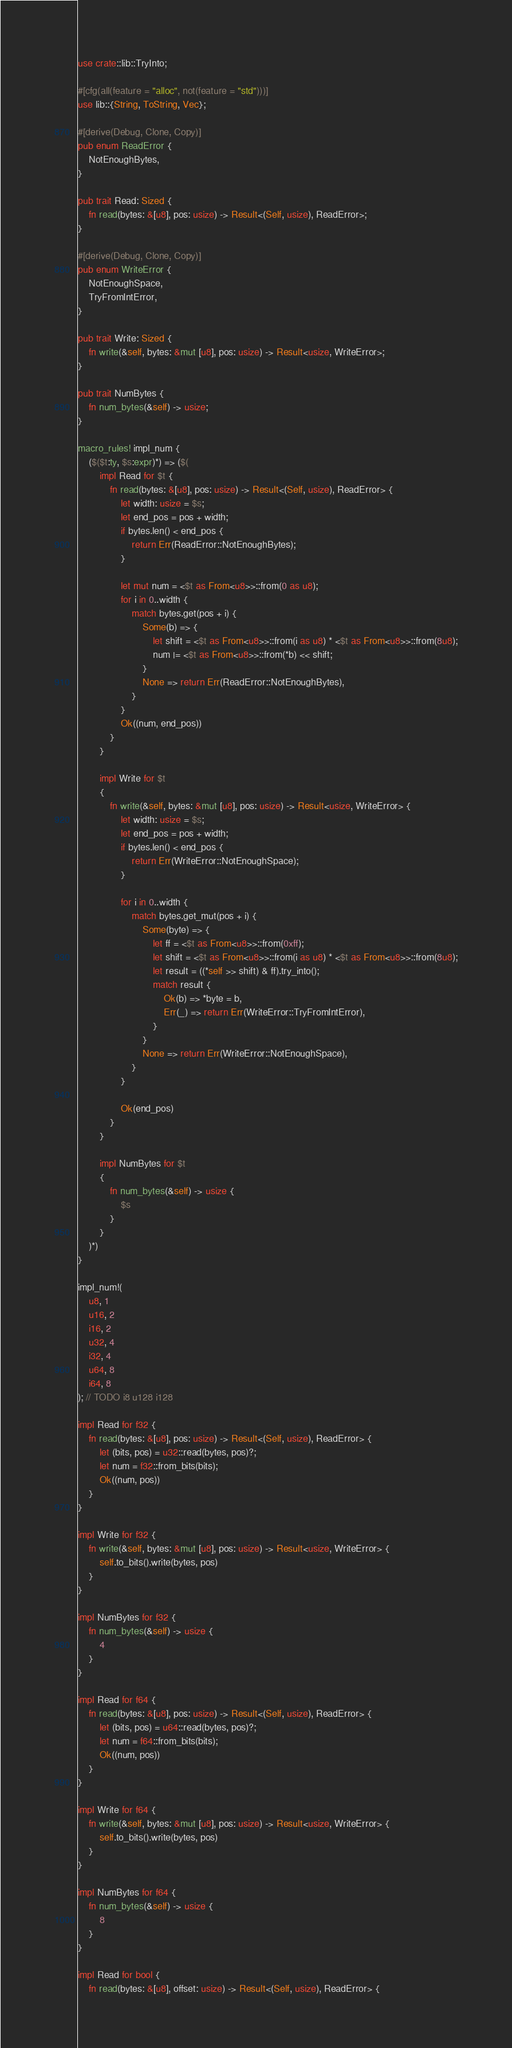Convert code to text. <code><loc_0><loc_0><loc_500><loc_500><_Rust_>use crate::lib::TryInto;

#[cfg(all(feature = "alloc", not(feature = "std")))]
use lib::{String, ToString, Vec};

#[derive(Debug, Clone, Copy)]
pub enum ReadError {
    NotEnoughBytes,
}

pub trait Read: Sized {
    fn read(bytes: &[u8], pos: usize) -> Result<(Self, usize), ReadError>;
}

#[derive(Debug, Clone, Copy)]
pub enum WriteError {
    NotEnoughSpace,
    TryFromIntError,
}

pub trait Write: Sized {
    fn write(&self, bytes: &mut [u8], pos: usize) -> Result<usize, WriteError>;
}

pub trait NumBytes {
    fn num_bytes(&self) -> usize;
}

macro_rules! impl_num {
    ($($t:ty, $s:expr)*) => ($(
        impl Read for $t {
            fn read(bytes: &[u8], pos: usize) -> Result<(Self, usize), ReadError> {
                let width: usize = $s;
                let end_pos = pos + width;
                if bytes.len() < end_pos {
                    return Err(ReadError::NotEnoughBytes);
                }

                let mut num = <$t as From<u8>>::from(0 as u8);
                for i in 0..width {
                    match bytes.get(pos + i) {
                        Some(b) => {
                            let shift = <$t as From<u8>>::from(i as u8) * <$t as From<u8>>::from(8u8);
                            num |= <$t as From<u8>>::from(*b) << shift;
                        }
                        None => return Err(ReadError::NotEnoughBytes),
                    }
                }
                Ok((num, end_pos))
            }
        }

        impl Write for $t
        {
            fn write(&self, bytes: &mut [u8], pos: usize) -> Result<usize, WriteError> {
                let width: usize = $s;
                let end_pos = pos + width;
                if bytes.len() < end_pos {
                    return Err(WriteError::NotEnoughSpace);
                }

                for i in 0..width {
                    match bytes.get_mut(pos + i) {
                        Some(byte) => {
                            let ff = <$t as From<u8>>::from(0xff);
                            let shift = <$t as From<u8>>::from(i as u8) * <$t as From<u8>>::from(8u8);
                            let result = ((*self >> shift) & ff).try_into();
                            match result {
                                Ok(b) => *byte = b,
                                Err(_) => return Err(WriteError::TryFromIntError),
                            }
                        }
                        None => return Err(WriteError::NotEnoughSpace),
                    }
                }

                Ok(end_pos)
            }
        }

        impl NumBytes for $t
        {
            fn num_bytes(&self) -> usize {
                $s
            }
        }
    )*)
}

impl_num!(
    u8, 1
    u16, 2
    i16, 2
    u32, 4
    i32, 4
    u64, 8
    i64, 8
); // TODO i8 u128 i128

impl Read for f32 {
    fn read(bytes: &[u8], pos: usize) -> Result<(Self, usize), ReadError> {
        let (bits, pos) = u32::read(bytes, pos)?;
        let num = f32::from_bits(bits);
        Ok((num, pos))
    }
}

impl Write for f32 {
    fn write(&self, bytes: &mut [u8], pos: usize) -> Result<usize, WriteError> {
        self.to_bits().write(bytes, pos)
    }
}

impl NumBytes for f32 {
    fn num_bytes(&self) -> usize {
        4
    }
}

impl Read for f64 {
    fn read(bytes: &[u8], pos: usize) -> Result<(Self, usize), ReadError> {
        let (bits, pos) = u64::read(bytes, pos)?;
        let num = f64::from_bits(bits);
        Ok((num, pos))
    }
}

impl Write for f64 {
    fn write(&self, bytes: &mut [u8], pos: usize) -> Result<usize, WriteError> {
        self.to_bits().write(bytes, pos)
    }
}

impl NumBytes for f64 {
    fn num_bytes(&self) -> usize {
        8
    }
}

impl Read for bool {
    fn read(bytes: &[u8], offset: usize) -> Result<(Self, usize), ReadError> {</code> 